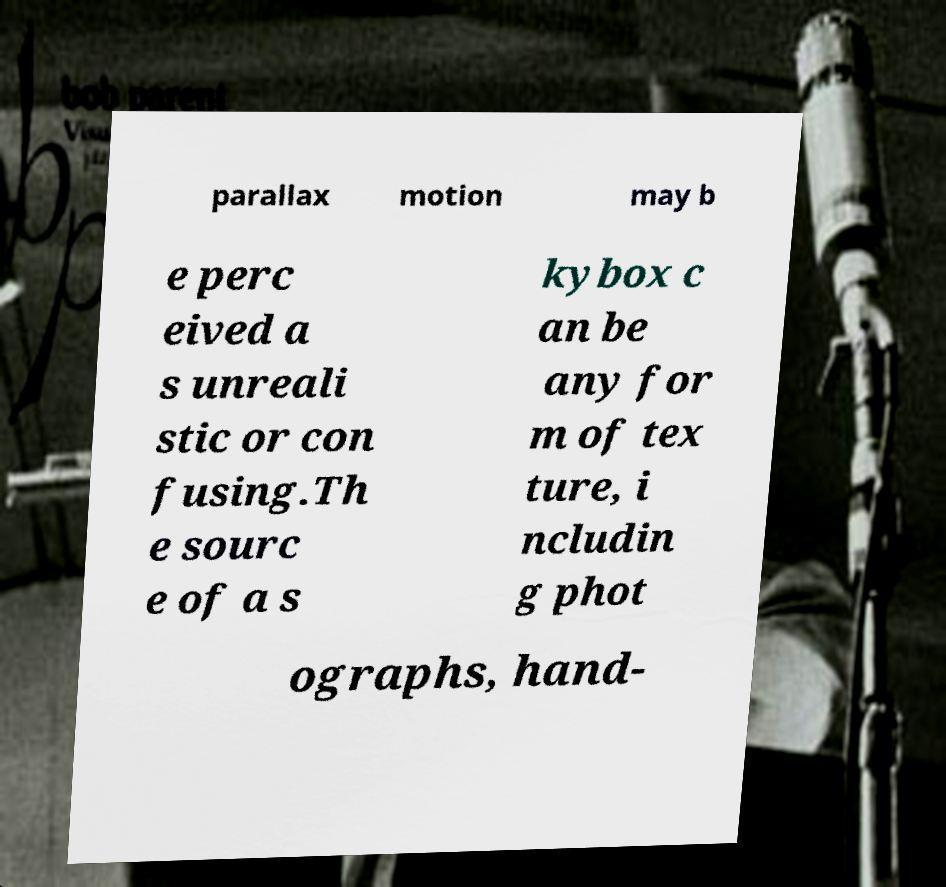There's text embedded in this image that I need extracted. Can you transcribe it verbatim? parallax motion may b e perc eived a s unreali stic or con fusing.Th e sourc e of a s kybox c an be any for m of tex ture, i ncludin g phot ographs, hand- 